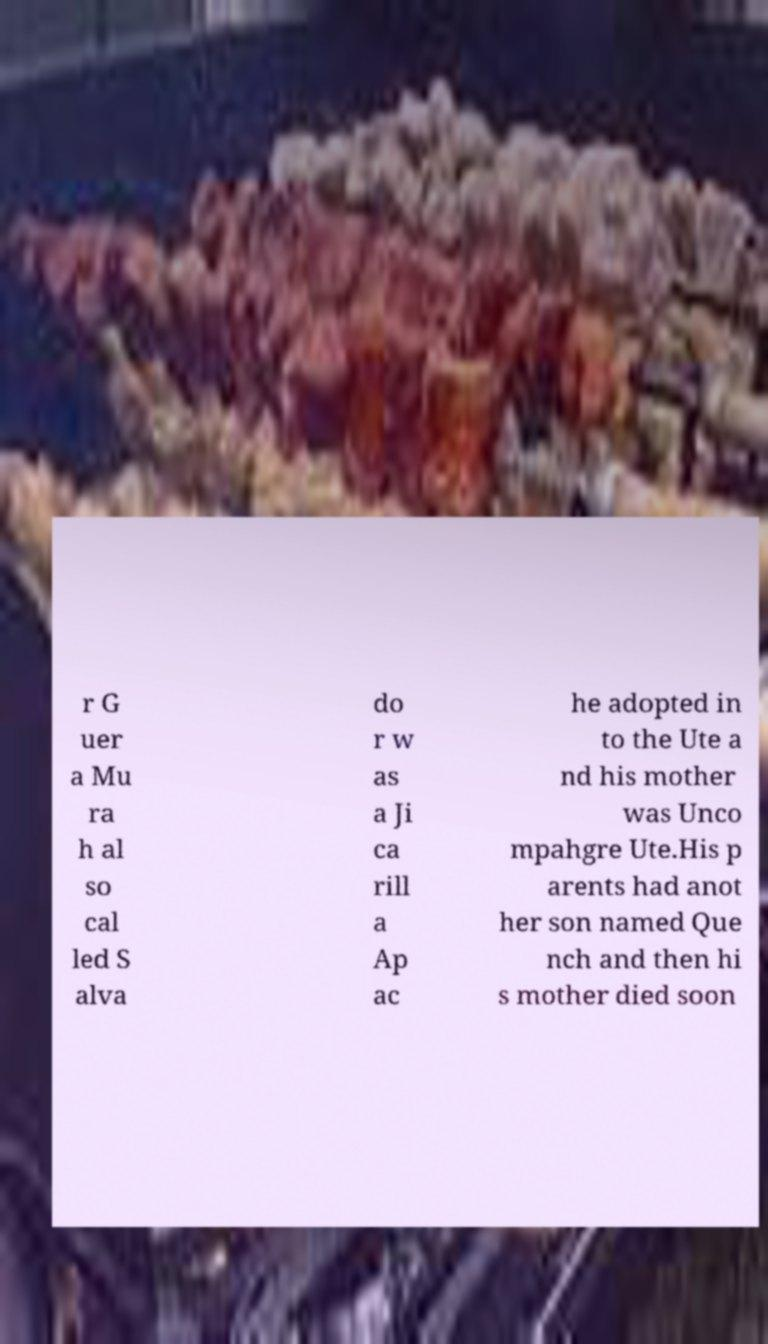Can you accurately transcribe the text from the provided image for me? r G uer a Mu ra h al so cal led S alva do r w as a Ji ca rill a Ap ac he adopted in to the Ute a nd his mother was Unco mpahgre Ute.His p arents had anot her son named Que nch and then hi s mother died soon 